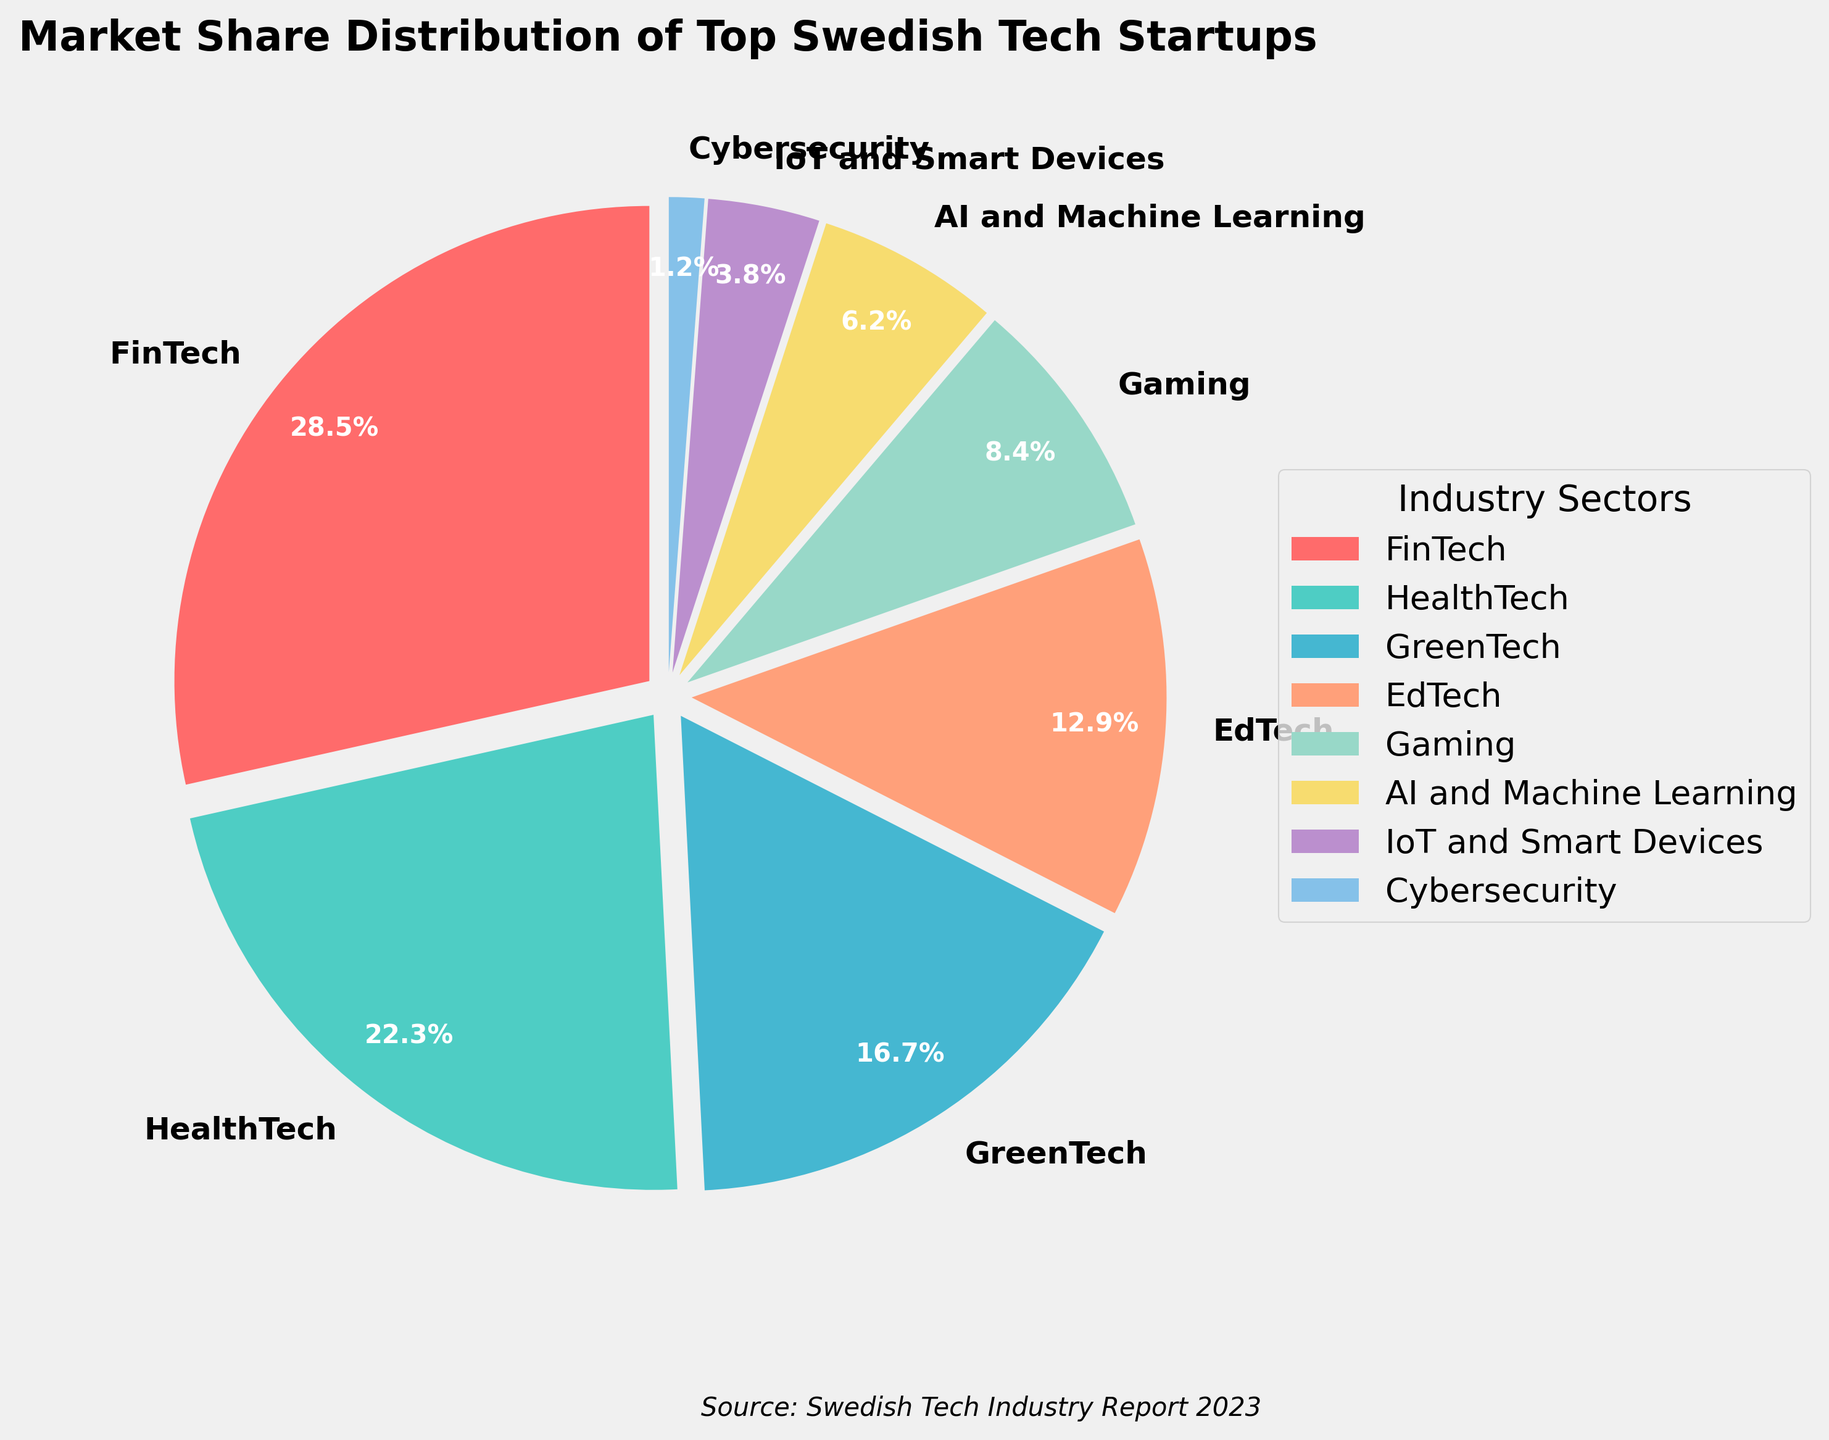What is the sector with the largest market share? The wedge labelled "FinTech" is the largest and shows a percentage of 28.5%.
Answer: FinTech Which sector has a smaller market share, AI and Machine Learning or Gaming? The wedge labelled "AI and Machine Learning" shows 6.2%, while the "Gaming" wedge shows 8.4%. Since 6.2% is less than 8.4%, "AI and Machine Learning" has a smaller market share.
Answer: AI and Machine Learning What is the combined market share of HealthTech, GreenTech, and EdTech? The percentages are 22.3% for HealthTech, 16.7% for GreenTech, and 12.9% for EdTech. Adding them gives 22.3 + 16.7 + 12.9 = 51.9%.
Answer: 51.9% Which sector has a market share closest to 25%? Among the sectors shown, FinTech has a market share of 28.5%, which is the closest to 25%.
Answer: FinTech How much larger is the market share of FinTech compared to Cybersecurity? FinTech has a market share of 28.5%, and Cybersecurity has 1.2%. The difference is 28.5 - 1.2 = 27.3%.
Answer: 27.3% Identify the sectors with a market share less than 10%. The wedges labelled "Gaming," "AI and Machine Learning," "IoT and Smart Devices," and "Cybersecurity" have market shares of 8.4%, 6.2%, 3.8%, and 1.2% respectively, all of which are less than 10%.
Answer: Gaming, AI and Machine Learning, IoT and Smart Devices, Cybersecurity What is the market share difference between EdTech and IoT and Smart Devices? EdTech has a market share of 12.9%, and IoT and Smart Devices has 3.8%. The difference is 12.9 - 3.8 = 9.1%.
Answer: 9.1% Which two sectors combined have a market share that surpasses GreenTech's market share? GreenTech has a market share of 16.7%. The sectors "Gaming" (8.4%) and "AI and Machine Learning" (6.2%) combined give 8.4 + 6.2 = 14.6%, which does not surpass. But combining "EdTech" (12.9%) and "AI and Machine Learning" (6.2%) gives 12.9 + 6.2 = 19.1%, which surpasses 16.7%.
Answer: EdTech and AI and Machine Learning 